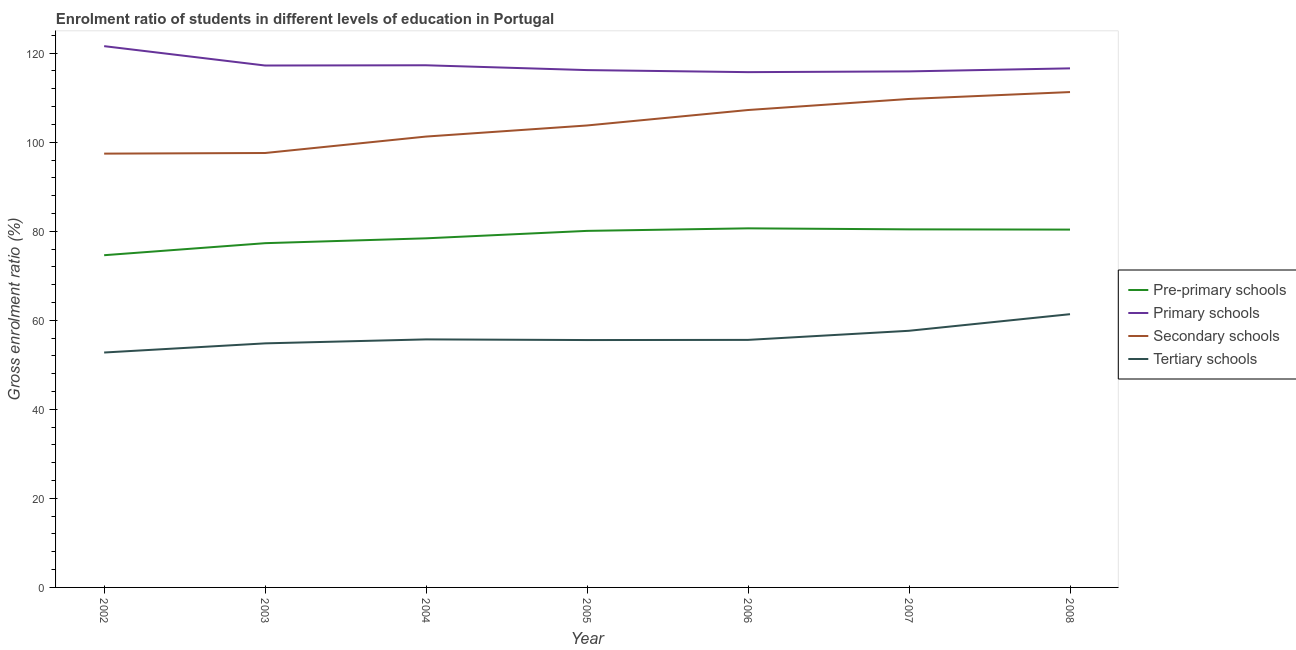Is the number of lines equal to the number of legend labels?
Keep it short and to the point. Yes. What is the gross enrolment ratio in primary schools in 2003?
Give a very brief answer. 117.22. Across all years, what is the maximum gross enrolment ratio in pre-primary schools?
Your response must be concise. 80.65. Across all years, what is the minimum gross enrolment ratio in pre-primary schools?
Give a very brief answer. 74.62. In which year was the gross enrolment ratio in pre-primary schools minimum?
Ensure brevity in your answer.  2002. What is the total gross enrolment ratio in primary schools in the graph?
Your answer should be very brief. 820.5. What is the difference between the gross enrolment ratio in tertiary schools in 2005 and that in 2008?
Your response must be concise. -5.81. What is the difference between the gross enrolment ratio in pre-primary schools in 2004 and the gross enrolment ratio in tertiary schools in 2006?
Your answer should be compact. 22.81. What is the average gross enrolment ratio in primary schools per year?
Provide a succinct answer. 117.21. In the year 2007, what is the difference between the gross enrolment ratio in tertiary schools and gross enrolment ratio in secondary schools?
Ensure brevity in your answer.  -52.07. What is the ratio of the gross enrolment ratio in primary schools in 2006 to that in 2007?
Provide a short and direct response. 1. Is the difference between the gross enrolment ratio in secondary schools in 2003 and 2005 greater than the difference between the gross enrolment ratio in pre-primary schools in 2003 and 2005?
Give a very brief answer. No. What is the difference between the highest and the second highest gross enrolment ratio in primary schools?
Your response must be concise. 4.3. What is the difference between the highest and the lowest gross enrolment ratio in primary schools?
Provide a short and direct response. 5.84. Is the sum of the gross enrolment ratio in tertiary schools in 2005 and 2006 greater than the maximum gross enrolment ratio in pre-primary schools across all years?
Provide a short and direct response. Yes. Is it the case that in every year, the sum of the gross enrolment ratio in pre-primary schools and gross enrolment ratio in tertiary schools is greater than the sum of gross enrolment ratio in primary schools and gross enrolment ratio in secondary schools?
Keep it short and to the point. No. Does the gross enrolment ratio in secondary schools monotonically increase over the years?
Offer a very short reply. Yes. Is the gross enrolment ratio in tertiary schools strictly less than the gross enrolment ratio in secondary schools over the years?
Ensure brevity in your answer.  Yes. How many lines are there?
Offer a very short reply. 4. Are the values on the major ticks of Y-axis written in scientific E-notation?
Your answer should be very brief. No. Does the graph contain any zero values?
Ensure brevity in your answer.  No. Where does the legend appear in the graph?
Your answer should be compact. Center right. How are the legend labels stacked?
Provide a short and direct response. Vertical. What is the title of the graph?
Ensure brevity in your answer.  Enrolment ratio of students in different levels of education in Portugal. What is the Gross enrolment ratio (%) in Pre-primary schools in 2002?
Provide a short and direct response. 74.62. What is the Gross enrolment ratio (%) in Primary schools in 2002?
Your answer should be very brief. 121.57. What is the Gross enrolment ratio (%) of Secondary schools in 2002?
Your answer should be very brief. 97.43. What is the Gross enrolment ratio (%) in Tertiary schools in 2002?
Offer a terse response. 52.76. What is the Gross enrolment ratio (%) of Pre-primary schools in 2003?
Offer a terse response. 77.32. What is the Gross enrolment ratio (%) in Primary schools in 2003?
Give a very brief answer. 117.22. What is the Gross enrolment ratio (%) of Secondary schools in 2003?
Provide a short and direct response. 97.58. What is the Gross enrolment ratio (%) in Tertiary schools in 2003?
Provide a succinct answer. 54.82. What is the Gross enrolment ratio (%) of Pre-primary schools in 2004?
Offer a very short reply. 78.41. What is the Gross enrolment ratio (%) in Primary schools in 2004?
Your answer should be compact. 117.28. What is the Gross enrolment ratio (%) of Secondary schools in 2004?
Provide a succinct answer. 101.27. What is the Gross enrolment ratio (%) of Tertiary schools in 2004?
Keep it short and to the point. 55.71. What is the Gross enrolment ratio (%) of Pre-primary schools in 2005?
Provide a short and direct response. 80.08. What is the Gross enrolment ratio (%) in Primary schools in 2005?
Your answer should be very brief. 116.2. What is the Gross enrolment ratio (%) in Secondary schools in 2005?
Provide a short and direct response. 103.76. What is the Gross enrolment ratio (%) in Tertiary schools in 2005?
Provide a succinct answer. 55.56. What is the Gross enrolment ratio (%) in Pre-primary schools in 2006?
Your answer should be compact. 80.65. What is the Gross enrolment ratio (%) of Primary schools in 2006?
Ensure brevity in your answer.  115.74. What is the Gross enrolment ratio (%) of Secondary schools in 2006?
Offer a very short reply. 107.23. What is the Gross enrolment ratio (%) in Tertiary schools in 2006?
Provide a succinct answer. 55.6. What is the Gross enrolment ratio (%) in Pre-primary schools in 2007?
Ensure brevity in your answer.  80.43. What is the Gross enrolment ratio (%) in Primary schools in 2007?
Offer a very short reply. 115.9. What is the Gross enrolment ratio (%) in Secondary schools in 2007?
Provide a short and direct response. 109.71. What is the Gross enrolment ratio (%) of Tertiary schools in 2007?
Offer a terse response. 57.64. What is the Gross enrolment ratio (%) in Pre-primary schools in 2008?
Provide a short and direct response. 80.37. What is the Gross enrolment ratio (%) of Primary schools in 2008?
Your answer should be compact. 116.58. What is the Gross enrolment ratio (%) in Secondary schools in 2008?
Offer a very short reply. 111.26. What is the Gross enrolment ratio (%) in Tertiary schools in 2008?
Give a very brief answer. 61.37. Across all years, what is the maximum Gross enrolment ratio (%) in Pre-primary schools?
Offer a terse response. 80.65. Across all years, what is the maximum Gross enrolment ratio (%) in Primary schools?
Make the answer very short. 121.57. Across all years, what is the maximum Gross enrolment ratio (%) of Secondary schools?
Offer a terse response. 111.26. Across all years, what is the maximum Gross enrolment ratio (%) of Tertiary schools?
Give a very brief answer. 61.37. Across all years, what is the minimum Gross enrolment ratio (%) of Pre-primary schools?
Offer a very short reply. 74.62. Across all years, what is the minimum Gross enrolment ratio (%) of Primary schools?
Ensure brevity in your answer.  115.74. Across all years, what is the minimum Gross enrolment ratio (%) in Secondary schools?
Your response must be concise. 97.43. Across all years, what is the minimum Gross enrolment ratio (%) of Tertiary schools?
Ensure brevity in your answer.  52.76. What is the total Gross enrolment ratio (%) in Pre-primary schools in the graph?
Your answer should be very brief. 551.88. What is the total Gross enrolment ratio (%) of Primary schools in the graph?
Provide a succinct answer. 820.5. What is the total Gross enrolment ratio (%) of Secondary schools in the graph?
Your answer should be compact. 728.24. What is the total Gross enrolment ratio (%) of Tertiary schools in the graph?
Offer a terse response. 393.47. What is the difference between the Gross enrolment ratio (%) in Pre-primary schools in 2002 and that in 2003?
Your response must be concise. -2.7. What is the difference between the Gross enrolment ratio (%) in Primary schools in 2002 and that in 2003?
Provide a short and direct response. 4.35. What is the difference between the Gross enrolment ratio (%) of Secondary schools in 2002 and that in 2003?
Offer a very short reply. -0.14. What is the difference between the Gross enrolment ratio (%) in Tertiary schools in 2002 and that in 2003?
Keep it short and to the point. -2.06. What is the difference between the Gross enrolment ratio (%) in Pre-primary schools in 2002 and that in 2004?
Make the answer very short. -3.79. What is the difference between the Gross enrolment ratio (%) in Primary schools in 2002 and that in 2004?
Make the answer very short. 4.3. What is the difference between the Gross enrolment ratio (%) in Secondary schools in 2002 and that in 2004?
Keep it short and to the point. -3.83. What is the difference between the Gross enrolment ratio (%) of Tertiary schools in 2002 and that in 2004?
Give a very brief answer. -2.95. What is the difference between the Gross enrolment ratio (%) of Pre-primary schools in 2002 and that in 2005?
Offer a very short reply. -5.47. What is the difference between the Gross enrolment ratio (%) in Primary schools in 2002 and that in 2005?
Your response must be concise. 5.38. What is the difference between the Gross enrolment ratio (%) in Secondary schools in 2002 and that in 2005?
Offer a terse response. -6.33. What is the difference between the Gross enrolment ratio (%) in Tertiary schools in 2002 and that in 2005?
Offer a very short reply. -2.8. What is the difference between the Gross enrolment ratio (%) in Pre-primary schools in 2002 and that in 2006?
Offer a terse response. -6.04. What is the difference between the Gross enrolment ratio (%) in Primary schools in 2002 and that in 2006?
Your answer should be compact. 5.84. What is the difference between the Gross enrolment ratio (%) in Secondary schools in 2002 and that in 2006?
Keep it short and to the point. -9.8. What is the difference between the Gross enrolment ratio (%) in Tertiary schools in 2002 and that in 2006?
Your response must be concise. -2.84. What is the difference between the Gross enrolment ratio (%) in Pre-primary schools in 2002 and that in 2007?
Give a very brief answer. -5.81. What is the difference between the Gross enrolment ratio (%) in Primary schools in 2002 and that in 2007?
Ensure brevity in your answer.  5.67. What is the difference between the Gross enrolment ratio (%) in Secondary schools in 2002 and that in 2007?
Offer a very short reply. -12.28. What is the difference between the Gross enrolment ratio (%) in Tertiary schools in 2002 and that in 2007?
Make the answer very short. -4.88. What is the difference between the Gross enrolment ratio (%) of Pre-primary schools in 2002 and that in 2008?
Ensure brevity in your answer.  -5.76. What is the difference between the Gross enrolment ratio (%) in Primary schools in 2002 and that in 2008?
Ensure brevity in your answer.  4.99. What is the difference between the Gross enrolment ratio (%) in Secondary schools in 2002 and that in 2008?
Keep it short and to the point. -13.83. What is the difference between the Gross enrolment ratio (%) in Tertiary schools in 2002 and that in 2008?
Offer a very short reply. -8.61. What is the difference between the Gross enrolment ratio (%) of Pre-primary schools in 2003 and that in 2004?
Provide a succinct answer. -1.09. What is the difference between the Gross enrolment ratio (%) of Primary schools in 2003 and that in 2004?
Provide a succinct answer. -0.06. What is the difference between the Gross enrolment ratio (%) of Secondary schools in 2003 and that in 2004?
Keep it short and to the point. -3.69. What is the difference between the Gross enrolment ratio (%) in Tertiary schools in 2003 and that in 2004?
Provide a succinct answer. -0.89. What is the difference between the Gross enrolment ratio (%) of Pre-primary schools in 2003 and that in 2005?
Ensure brevity in your answer.  -2.76. What is the difference between the Gross enrolment ratio (%) in Primary schools in 2003 and that in 2005?
Provide a succinct answer. 1.03. What is the difference between the Gross enrolment ratio (%) of Secondary schools in 2003 and that in 2005?
Make the answer very short. -6.18. What is the difference between the Gross enrolment ratio (%) of Tertiary schools in 2003 and that in 2005?
Offer a terse response. -0.75. What is the difference between the Gross enrolment ratio (%) of Pre-primary schools in 2003 and that in 2006?
Make the answer very short. -3.33. What is the difference between the Gross enrolment ratio (%) in Primary schools in 2003 and that in 2006?
Make the answer very short. 1.49. What is the difference between the Gross enrolment ratio (%) in Secondary schools in 2003 and that in 2006?
Keep it short and to the point. -9.65. What is the difference between the Gross enrolment ratio (%) in Tertiary schools in 2003 and that in 2006?
Offer a terse response. -0.78. What is the difference between the Gross enrolment ratio (%) in Pre-primary schools in 2003 and that in 2007?
Offer a terse response. -3.11. What is the difference between the Gross enrolment ratio (%) in Primary schools in 2003 and that in 2007?
Provide a succinct answer. 1.32. What is the difference between the Gross enrolment ratio (%) of Secondary schools in 2003 and that in 2007?
Offer a terse response. -12.14. What is the difference between the Gross enrolment ratio (%) in Tertiary schools in 2003 and that in 2007?
Give a very brief answer. -2.83. What is the difference between the Gross enrolment ratio (%) in Pre-primary schools in 2003 and that in 2008?
Keep it short and to the point. -3.05. What is the difference between the Gross enrolment ratio (%) in Primary schools in 2003 and that in 2008?
Your answer should be very brief. 0.64. What is the difference between the Gross enrolment ratio (%) in Secondary schools in 2003 and that in 2008?
Provide a short and direct response. -13.69. What is the difference between the Gross enrolment ratio (%) in Tertiary schools in 2003 and that in 2008?
Offer a very short reply. -6.55. What is the difference between the Gross enrolment ratio (%) of Pre-primary schools in 2004 and that in 2005?
Give a very brief answer. -1.67. What is the difference between the Gross enrolment ratio (%) in Primary schools in 2004 and that in 2005?
Your answer should be very brief. 1.08. What is the difference between the Gross enrolment ratio (%) in Secondary schools in 2004 and that in 2005?
Give a very brief answer. -2.49. What is the difference between the Gross enrolment ratio (%) in Tertiary schools in 2004 and that in 2005?
Your response must be concise. 0.15. What is the difference between the Gross enrolment ratio (%) in Pre-primary schools in 2004 and that in 2006?
Your answer should be compact. -2.24. What is the difference between the Gross enrolment ratio (%) in Primary schools in 2004 and that in 2006?
Your answer should be very brief. 1.54. What is the difference between the Gross enrolment ratio (%) of Secondary schools in 2004 and that in 2006?
Your response must be concise. -5.96. What is the difference between the Gross enrolment ratio (%) of Tertiary schools in 2004 and that in 2006?
Provide a succinct answer. 0.11. What is the difference between the Gross enrolment ratio (%) in Pre-primary schools in 2004 and that in 2007?
Your response must be concise. -2.01. What is the difference between the Gross enrolment ratio (%) in Primary schools in 2004 and that in 2007?
Offer a very short reply. 1.37. What is the difference between the Gross enrolment ratio (%) in Secondary schools in 2004 and that in 2007?
Offer a very short reply. -8.45. What is the difference between the Gross enrolment ratio (%) in Tertiary schools in 2004 and that in 2007?
Your answer should be very brief. -1.93. What is the difference between the Gross enrolment ratio (%) of Pre-primary schools in 2004 and that in 2008?
Provide a succinct answer. -1.96. What is the difference between the Gross enrolment ratio (%) of Primary schools in 2004 and that in 2008?
Provide a short and direct response. 0.69. What is the difference between the Gross enrolment ratio (%) of Secondary schools in 2004 and that in 2008?
Offer a terse response. -9.99. What is the difference between the Gross enrolment ratio (%) in Tertiary schools in 2004 and that in 2008?
Ensure brevity in your answer.  -5.66. What is the difference between the Gross enrolment ratio (%) in Pre-primary schools in 2005 and that in 2006?
Your response must be concise. -0.57. What is the difference between the Gross enrolment ratio (%) of Primary schools in 2005 and that in 2006?
Your answer should be very brief. 0.46. What is the difference between the Gross enrolment ratio (%) in Secondary schools in 2005 and that in 2006?
Ensure brevity in your answer.  -3.47. What is the difference between the Gross enrolment ratio (%) in Tertiary schools in 2005 and that in 2006?
Ensure brevity in your answer.  -0.04. What is the difference between the Gross enrolment ratio (%) in Pre-primary schools in 2005 and that in 2007?
Offer a terse response. -0.34. What is the difference between the Gross enrolment ratio (%) in Primary schools in 2005 and that in 2007?
Your response must be concise. 0.29. What is the difference between the Gross enrolment ratio (%) of Secondary schools in 2005 and that in 2007?
Provide a succinct answer. -5.95. What is the difference between the Gross enrolment ratio (%) in Tertiary schools in 2005 and that in 2007?
Give a very brief answer. -2.08. What is the difference between the Gross enrolment ratio (%) in Pre-primary schools in 2005 and that in 2008?
Ensure brevity in your answer.  -0.29. What is the difference between the Gross enrolment ratio (%) in Primary schools in 2005 and that in 2008?
Your response must be concise. -0.39. What is the difference between the Gross enrolment ratio (%) in Secondary schools in 2005 and that in 2008?
Your response must be concise. -7.5. What is the difference between the Gross enrolment ratio (%) of Tertiary schools in 2005 and that in 2008?
Provide a succinct answer. -5.81. What is the difference between the Gross enrolment ratio (%) of Pre-primary schools in 2006 and that in 2007?
Your answer should be very brief. 0.23. What is the difference between the Gross enrolment ratio (%) of Primary schools in 2006 and that in 2007?
Provide a short and direct response. -0.17. What is the difference between the Gross enrolment ratio (%) in Secondary schools in 2006 and that in 2007?
Give a very brief answer. -2.48. What is the difference between the Gross enrolment ratio (%) in Tertiary schools in 2006 and that in 2007?
Make the answer very short. -2.05. What is the difference between the Gross enrolment ratio (%) of Pre-primary schools in 2006 and that in 2008?
Keep it short and to the point. 0.28. What is the difference between the Gross enrolment ratio (%) of Primary schools in 2006 and that in 2008?
Keep it short and to the point. -0.85. What is the difference between the Gross enrolment ratio (%) of Secondary schools in 2006 and that in 2008?
Offer a very short reply. -4.03. What is the difference between the Gross enrolment ratio (%) in Tertiary schools in 2006 and that in 2008?
Your answer should be compact. -5.77. What is the difference between the Gross enrolment ratio (%) in Pre-primary schools in 2007 and that in 2008?
Give a very brief answer. 0.05. What is the difference between the Gross enrolment ratio (%) of Primary schools in 2007 and that in 2008?
Your answer should be compact. -0.68. What is the difference between the Gross enrolment ratio (%) of Secondary schools in 2007 and that in 2008?
Your answer should be very brief. -1.55. What is the difference between the Gross enrolment ratio (%) of Tertiary schools in 2007 and that in 2008?
Your answer should be very brief. -3.73. What is the difference between the Gross enrolment ratio (%) in Pre-primary schools in 2002 and the Gross enrolment ratio (%) in Primary schools in 2003?
Provide a succinct answer. -42.61. What is the difference between the Gross enrolment ratio (%) in Pre-primary schools in 2002 and the Gross enrolment ratio (%) in Secondary schools in 2003?
Your answer should be very brief. -22.96. What is the difference between the Gross enrolment ratio (%) of Pre-primary schools in 2002 and the Gross enrolment ratio (%) of Tertiary schools in 2003?
Provide a short and direct response. 19.8. What is the difference between the Gross enrolment ratio (%) in Primary schools in 2002 and the Gross enrolment ratio (%) in Secondary schools in 2003?
Offer a very short reply. 24. What is the difference between the Gross enrolment ratio (%) of Primary schools in 2002 and the Gross enrolment ratio (%) of Tertiary schools in 2003?
Ensure brevity in your answer.  66.76. What is the difference between the Gross enrolment ratio (%) of Secondary schools in 2002 and the Gross enrolment ratio (%) of Tertiary schools in 2003?
Provide a short and direct response. 42.62. What is the difference between the Gross enrolment ratio (%) in Pre-primary schools in 2002 and the Gross enrolment ratio (%) in Primary schools in 2004?
Provide a succinct answer. -42.66. What is the difference between the Gross enrolment ratio (%) in Pre-primary schools in 2002 and the Gross enrolment ratio (%) in Secondary schools in 2004?
Ensure brevity in your answer.  -26.65. What is the difference between the Gross enrolment ratio (%) of Pre-primary schools in 2002 and the Gross enrolment ratio (%) of Tertiary schools in 2004?
Your answer should be very brief. 18.91. What is the difference between the Gross enrolment ratio (%) in Primary schools in 2002 and the Gross enrolment ratio (%) in Secondary schools in 2004?
Your answer should be very brief. 20.31. What is the difference between the Gross enrolment ratio (%) of Primary schools in 2002 and the Gross enrolment ratio (%) of Tertiary schools in 2004?
Your response must be concise. 65.86. What is the difference between the Gross enrolment ratio (%) in Secondary schools in 2002 and the Gross enrolment ratio (%) in Tertiary schools in 2004?
Ensure brevity in your answer.  41.72. What is the difference between the Gross enrolment ratio (%) in Pre-primary schools in 2002 and the Gross enrolment ratio (%) in Primary schools in 2005?
Your response must be concise. -41.58. What is the difference between the Gross enrolment ratio (%) in Pre-primary schools in 2002 and the Gross enrolment ratio (%) in Secondary schools in 2005?
Ensure brevity in your answer.  -29.14. What is the difference between the Gross enrolment ratio (%) in Pre-primary schools in 2002 and the Gross enrolment ratio (%) in Tertiary schools in 2005?
Your answer should be compact. 19.05. What is the difference between the Gross enrolment ratio (%) in Primary schools in 2002 and the Gross enrolment ratio (%) in Secondary schools in 2005?
Your response must be concise. 17.82. What is the difference between the Gross enrolment ratio (%) in Primary schools in 2002 and the Gross enrolment ratio (%) in Tertiary schools in 2005?
Give a very brief answer. 66.01. What is the difference between the Gross enrolment ratio (%) in Secondary schools in 2002 and the Gross enrolment ratio (%) in Tertiary schools in 2005?
Your response must be concise. 41.87. What is the difference between the Gross enrolment ratio (%) in Pre-primary schools in 2002 and the Gross enrolment ratio (%) in Primary schools in 2006?
Your answer should be very brief. -41.12. What is the difference between the Gross enrolment ratio (%) of Pre-primary schools in 2002 and the Gross enrolment ratio (%) of Secondary schools in 2006?
Give a very brief answer. -32.61. What is the difference between the Gross enrolment ratio (%) in Pre-primary schools in 2002 and the Gross enrolment ratio (%) in Tertiary schools in 2006?
Give a very brief answer. 19.02. What is the difference between the Gross enrolment ratio (%) in Primary schools in 2002 and the Gross enrolment ratio (%) in Secondary schools in 2006?
Offer a terse response. 14.35. What is the difference between the Gross enrolment ratio (%) of Primary schools in 2002 and the Gross enrolment ratio (%) of Tertiary schools in 2006?
Offer a very short reply. 65.98. What is the difference between the Gross enrolment ratio (%) in Secondary schools in 2002 and the Gross enrolment ratio (%) in Tertiary schools in 2006?
Provide a succinct answer. 41.83. What is the difference between the Gross enrolment ratio (%) in Pre-primary schools in 2002 and the Gross enrolment ratio (%) in Primary schools in 2007?
Provide a short and direct response. -41.29. What is the difference between the Gross enrolment ratio (%) in Pre-primary schools in 2002 and the Gross enrolment ratio (%) in Secondary schools in 2007?
Make the answer very short. -35.1. What is the difference between the Gross enrolment ratio (%) in Pre-primary schools in 2002 and the Gross enrolment ratio (%) in Tertiary schools in 2007?
Provide a succinct answer. 16.97. What is the difference between the Gross enrolment ratio (%) of Primary schools in 2002 and the Gross enrolment ratio (%) of Secondary schools in 2007?
Offer a terse response. 11.86. What is the difference between the Gross enrolment ratio (%) of Primary schools in 2002 and the Gross enrolment ratio (%) of Tertiary schools in 2007?
Your answer should be compact. 63.93. What is the difference between the Gross enrolment ratio (%) of Secondary schools in 2002 and the Gross enrolment ratio (%) of Tertiary schools in 2007?
Offer a terse response. 39.79. What is the difference between the Gross enrolment ratio (%) in Pre-primary schools in 2002 and the Gross enrolment ratio (%) in Primary schools in 2008?
Offer a very short reply. -41.97. What is the difference between the Gross enrolment ratio (%) in Pre-primary schools in 2002 and the Gross enrolment ratio (%) in Secondary schools in 2008?
Give a very brief answer. -36.64. What is the difference between the Gross enrolment ratio (%) of Pre-primary schools in 2002 and the Gross enrolment ratio (%) of Tertiary schools in 2008?
Keep it short and to the point. 13.25. What is the difference between the Gross enrolment ratio (%) of Primary schools in 2002 and the Gross enrolment ratio (%) of Secondary schools in 2008?
Provide a short and direct response. 10.31. What is the difference between the Gross enrolment ratio (%) in Primary schools in 2002 and the Gross enrolment ratio (%) in Tertiary schools in 2008?
Your answer should be very brief. 60.2. What is the difference between the Gross enrolment ratio (%) of Secondary schools in 2002 and the Gross enrolment ratio (%) of Tertiary schools in 2008?
Make the answer very short. 36.06. What is the difference between the Gross enrolment ratio (%) of Pre-primary schools in 2003 and the Gross enrolment ratio (%) of Primary schools in 2004?
Your answer should be very brief. -39.96. What is the difference between the Gross enrolment ratio (%) of Pre-primary schools in 2003 and the Gross enrolment ratio (%) of Secondary schools in 2004?
Give a very brief answer. -23.95. What is the difference between the Gross enrolment ratio (%) in Pre-primary schools in 2003 and the Gross enrolment ratio (%) in Tertiary schools in 2004?
Ensure brevity in your answer.  21.61. What is the difference between the Gross enrolment ratio (%) of Primary schools in 2003 and the Gross enrolment ratio (%) of Secondary schools in 2004?
Make the answer very short. 15.95. What is the difference between the Gross enrolment ratio (%) in Primary schools in 2003 and the Gross enrolment ratio (%) in Tertiary schools in 2004?
Ensure brevity in your answer.  61.51. What is the difference between the Gross enrolment ratio (%) in Secondary schools in 2003 and the Gross enrolment ratio (%) in Tertiary schools in 2004?
Provide a succinct answer. 41.86. What is the difference between the Gross enrolment ratio (%) in Pre-primary schools in 2003 and the Gross enrolment ratio (%) in Primary schools in 2005?
Keep it short and to the point. -38.88. What is the difference between the Gross enrolment ratio (%) of Pre-primary schools in 2003 and the Gross enrolment ratio (%) of Secondary schools in 2005?
Your response must be concise. -26.44. What is the difference between the Gross enrolment ratio (%) in Pre-primary schools in 2003 and the Gross enrolment ratio (%) in Tertiary schools in 2005?
Offer a terse response. 21.76. What is the difference between the Gross enrolment ratio (%) of Primary schools in 2003 and the Gross enrolment ratio (%) of Secondary schools in 2005?
Provide a succinct answer. 13.46. What is the difference between the Gross enrolment ratio (%) of Primary schools in 2003 and the Gross enrolment ratio (%) of Tertiary schools in 2005?
Offer a very short reply. 61.66. What is the difference between the Gross enrolment ratio (%) of Secondary schools in 2003 and the Gross enrolment ratio (%) of Tertiary schools in 2005?
Ensure brevity in your answer.  42.01. What is the difference between the Gross enrolment ratio (%) of Pre-primary schools in 2003 and the Gross enrolment ratio (%) of Primary schools in 2006?
Your response must be concise. -38.42. What is the difference between the Gross enrolment ratio (%) of Pre-primary schools in 2003 and the Gross enrolment ratio (%) of Secondary schools in 2006?
Keep it short and to the point. -29.91. What is the difference between the Gross enrolment ratio (%) of Pre-primary schools in 2003 and the Gross enrolment ratio (%) of Tertiary schools in 2006?
Your answer should be compact. 21.72. What is the difference between the Gross enrolment ratio (%) of Primary schools in 2003 and the Gross enrolment ratio (%) of Secondary schools in 2006?
Keep it short and to the point. 9.99. What is the difference between the Gross enrolment ratio (%) in Primary schools in 2003 and the Gross enrolment ratio (%) in Tertiary schools in 2006?
Offer a terse response. 61.62. What is the difference between the Gross enrolment ratio (%) in Secondary schools in 2003 and the Gross enrolment ratio (%) in Tertiary schools in 2006?
Give a very brief answer. 41.98. What is the difference between the Gross enrolment ratio (%) in Pre-primary schools in 2003 and the Gross enrolment ratio (%) in Primary schools in 2007?
Provide a succinct answer. -38.58. What is the difference between the Gross enrolment ratio (%) of Pre-primary schools in 2003 and the Gross enrolment ratio (%) of Secondary schools in 2007?
Offer a very short reply. -32.39. What is the difference between the Gross enrolment ratio (%) of Pre-primary schools in 2003 and the Gross enrolment ratio (%) of Tertiary schools in 2007?
Your response must be concise. 19.68. What is the difference between the Gross enrolment ratio (%) of Primary schools in 2003 and the Gross enrolment ratio (%) of Secondary schools in 2007?
Your response must be concise. 7.51. What is the difference between the Gross enrolment ratio (%) in Primary schools in 2003 and the Gross enrolment ratio (%) in Tertiary schools in 2007?
Keep it short and to the point. 59.58. What is the difference between the Gross enrolment ratio (%) of Secondary schools in 2003 and the Gross enrolment ratio (%) of Tertiary schools in 2007?
Provide a succinct answer. 39.93. What is the difference between the Gross enrolment ratio (%) of Pre-primary schools in 2003 and the Gross enrolment ratio (%) of Primary schools in 2008?
Your response must be concise. -39.26. What is the difference between the Gross enrolment ratio (%) of Pre-primary schools in 2003 and the Gross enrolment ratio (%) of Secondary schools in 2008?
Make the answer very short. -33.94. What is the difference between the Gross enrolment ratio (%) of Pre-primary schools in 2003 and the Gross enrolment ratio (%) of Tertiary schools in 2008?
Ensure brevity in your answer.  15.95. What is the difference between the Gross enrolment ratio (%) in Primary schools in 2003 and the Gross enrolment ratio (%) in Secondary schools in 2008?
Provide a succinct answer. 5.96. What is the difference between the Gross enrolment ratio (%) in Primary schools in 2003 and the Gross enrolment ratio (%) in Tertiary schools in 2008?
Your answer should be compact. 55.85. What is the difference between the Gross enrolment ratio (%) in Secondary schools in 2003 and the Gross enrolment ratio (%) in Tertiary schools in 2008?
Give a very brief answer. 36.2. What is the difference between the Gross enrolment ratio (%) of Pre-primary schools in 2004 and the Gross enrolment ratio (%) of Primary schools in 2005?
Give a very brief answer. -37.78. What is the difference between the Gross enrolment ratio (%) of Pre-primary schools in 2004 and the Gross enrolment ratio (%) of Secondary schools in 2005?
Provide a short and direct response. -25.35. What is the difference between the Gross enrolment ratio (%) in Pre-primary schools in 2004 and the Gross enrolment ratio (%) in Tertiary schools in 2005?
Make the answer very short. 22.85. What is the difference between the Gross enrolment ratio (%) of Primary schools in 2004 and the Gross enrolment ratio (%) of Secondary schools in 2005?
Your answer should be compact. 13.52. What is the difference between the Gross enrolment ratio (%) in Primary schools in 2004 and the Gross enrolment ratio (%) in Tertiary schools in 2005?
Provide a succinct answer. 61.72. What is the difference between the Gross enrolment ratio (%) in Secondary schools in 2004 and the Gross enrolment ratio (%) in Tertiary schools in 2005?
Make the answer very short. 45.7. What is the difference between the Gross enrolment ratio (%) in Pre-primary schools in 2004 and the Gross enrolment ratio (%) in Primary schools in 2006?
Your response must be concise. -37.33. What is the difference between the Gross enrolment ratio (%) of Pre-primary schools in 2004 and the Gross enrolment ratio (%) of Secondary schools in 2006?
Offer a very short reply. -28.82. What is the difference between the Gross enrolment ratio (%) in Pre-primary schools in 2004 and the Gross enrolment ratio (%) in Tertiary schools in 2006?
Ensure brevity in your answer.  22.81. What is the difference between the Gross enrolment ratio (%) in Primary schools in 2004 and the Gross enrolment ratio (%) in Secondary schools in 2006?
Your answer should be compact. 10.05. What is the difference between the Gross enrolment ratio (%) in Primary schools in 2004 and the Gross enrolment ratio (%) in Tertiary schools in 2006?
Provide a succinct answer. 61.68. What is the difference between the Gross enrolment ratio (%) of Secondary schools in 2004 and the Gross enrolment ratio (%) of Tertiary schools in 2006?
Ensure brevity in your answer.  45.67. What is the difference between the Gross enrolment ratio (%) of Pre-primary schools in 2004 and the Gross enrolment ratio (%) of Primary schools in 2007?
Your answer should be compact. -37.49. What is the difference between the Gross enrolment ratio (%) in Pre-primary schools in 2004 and the Gross enrolment ratio (%) in Secondary schools in 2007?
Provide a succinct answer. -31.3. What is the difference between the Gross enrolment ratio (%) in Pre-primary schools in 2004 and the Gross enrolment ratio (%) in Tertiary schools in 2007?
Provide a short and direct response. 20.77. What is the difference between the Gross enrolment ratio (%) in Primary schools in 2004 and the Gross enrolment ratio (%) in Secondary schools in 2007?
Make the answer very short. 7.57. What is the difference between the Gross enrolment ratio (%) in Primary schools in 2004 and the Gross enrolment ratio (%) in Tertiary schools in 2007?
Offer a very short reply. 59.63. What is the difference between the Gross enrolment ratio (%) of Secondary schools in 2004 and the Gross enrolment ratio (%) of Tertiary schools in 2007?
Keep it short and to the point. 43.62. What is the difference between the Gross enrolment ratio (%) in Pre-primary schools in 2004 and the Gross enrolment ratio (%) in Primary schools in 2008?
Your answer should be very brief. -38.17. What is the difference between the Gross enrolment ratio (%) of Pre-primary schools in 2004 and the Gross enrolment ratio (%) of Secondary schools in 2008?
Your response must be concise. -32.85. What is the difference between the Gross enrolment ratio (%) in Pre-primary schools in 2004 and the Gross enrolment ratio (%) in Tertiary schools in 2008?
Provide a succinct answer. 17.04. What is the difference between the Gross enrolment ratio (%) of Primary schools in 2004 and the Gross enrolment ratio (%) of Secondary schools in 2008?
Keep it short and to the point. 6.02. What is the difference between the Gross enrolment ratio (%) in Primary schools in 2004 and the Gross enrolment ratio (%) in Tertiary schools in 2008?
Offer a very short reply. 55.91. What is the difference between the Gross enrolment ratio (%) in Secondary schools in 2004 and the Gross enrolment ratio (%) in Tertiary schools in 2008?
Offer a very short reply. 39.9. What is the difference between the Gross enrolment ratio (%) in Pre-primary schools in 2005 and the Gross enrolment ratio (%) in Primary schools in 2006?
Provide a succinct answer. -35.65. What is the difference between the Gross enrolment ratio (%) of Pre-primary schools in 2005 and the Gross enrolment ratio (%) of Secondary schools in 2006?
Your answer should be very brief. -27.15. What is the difference between the Gross enrolment ratio (%) in Pre-primary schools in 2005 and the Gross enrolment ratio (%) in Tertiary schools in 2006?
Your response must be concise. 24.48. What is the difference between the Gross enrolment ratio (%) of Primary schools in 2005 and the Gross enrolment ratio (%) of Secondary schools in 2006?
Keep it short and to the point. 8.97. What is the difference between the Gross enrolment ratio (%) of Primary schools in 2005 and the Gross enrolment ratio (%) of Tertiary schools in 2006?
Give a very brief answer. 60.6. What is the difference between the Gross enrolment ratio (%) of Secondary schools in 2005 and the Gross enrolment ratio (%) of Tertiary schools in 2006?
Provide a succinct answer. 48.16. What is the difference between the Gross enrolment ratio (%) in Pre-primary schools in 2005 and the Gross enrolment ratio (%) in Primary schools in 2007?
Give a very brief answer. -35.82. What is the difference between the Gross enrolment ratio (%) of Pre-primary schools in 2005 and the Gross enrolment ratio (%) of Secondary schools in 2007?
Your answer should be very brief. -29.63. What is the difference between the Gross enrolment ratio (%) of Pre-primary schools in 2005 and the Gross enrolment ratio (%) of Tertiary schools in 2007?
Offer a very short reply. 22.44. What is the difference between the Gross enrolment ratio (%) of Primary schools in 2005 and the Gross enrolment ratio (%) of Secondary schools in 2007?
Provide a succinct answer. 6.48. What is the difference between the Gross enrolment ratio (%) of Primary schools in 2005 and the Gross enrolment ratio (%) of Tertiary schools in 2007?
Offer a terse response. 58.55. What is the difference between the Gross enrolment ratio (%) in Secondary schools in 2005 and the Gross enrolment ratio (%) in Tertiary schools in 2007?
Provide a succinct answer. 46.11. What is the difference between the Gross enrolment ratio (%) of Pre-primary schools in 2005 and the Gross enrolment ratio (%) of Primary schools in 2008?
Provide a succinct answer. -36.5. What is the difference between the Gross enrolment ratio (%) in Pre-primary schools in 2005 and the Gross enrolment ratio (%) in Secondary schools in 2008?
Your answer should be very brief. -31.18. What is the difference between the Gross enrolment ratio (%) of Pre-primary schools in 2005 and the Gross enrolment ratio (%) of Tertiary schools in 2008?
Your answer should be very brief. 18.71. What is the difference between the Gross enrolment ratio (%) in Primary schools in 2005 and the Gross enrolment ratio (%) in Secondary schools in 2008?
Offer a terse response. 4.94. What is the difference between the Gross enrolment ratio (%) in Primary schools in 2005 and the Gross enrolment ratio (%) in Tertiary schools in 2008?
Provide a succinct answer. 54.82. What is the difference between the Gross enrolment ratio (%) of Secondary schools in 2005 and the Gross enrolment ratio (%) of Tertiary schools in 2008?
Ensure brevity in your answer.  42.39. What is the difference between the Gross enrolment ratio (%) of Pre-primary schools in 2006 and the Gross enrolment ratio (%) of Primary schools in 2007?
Your answer should be compact. -35.25. What is the difference between the Gross enrolment ratio (%) of Pre-primary schools in 2006 and the Gross enrolment ratio (%) of Secondary schools in 2007?
Provide a short and direct response. -29.06. What is the difference between the Gross enrolment ratio (%) of Pre-primary schools in 2006 and the Gross enrolment ratio (%) of Tertiary schools in 2007?
Keep it short and to the point. 23.01. What is the difference between the Gross enrolment ratio (%) in Primary schools in 2006 and the Gross enrolment ratio (%) in Secondary schools in 2007?
Your answer should be very brief. 6.02. What is the difference between the Gross enrolment ratio (%) in Primary schools in 2006 and the Gross enrolment ratio (%) in Tertiary schools in 2007?
Keep it short and to the point. 58.09. What is the difference between the Gross enrolment ratio (%) in Secondary schools in 2006 and the Gross enrolment ratio (%) in Tertiary schools in 2007?
Give a very brief answer. 49.58. What is the difference between the Gross enrolment ratio (%) in Pre-primary schools in 2006 and the Gross enrolment ratio (%) in Primary schools in 2008?
Your answer should be compact. -35.93. What is the difference between the Gross enrolment ratio (%) in Pre-primary schools in 2006 and the Gross enrolment ratio (%) in Secondary schools in 2008?
Provide a succinct answer. -30.61. What is the difference between the Gross enrolment ratio (%) of Pre-primary schools in 2006 and the Gross enrolment ratio (%) of Tertiary schools in 2008?
Keep it short and to the point. 19.28. What is the difference between the Gross enrolment ratio (%) of Primary schools in 2006 and the Gross enrolment ratio (%) of Secondary schools in 2008?
Keep it short and to the point. 4.48. What is the difference between the Gross enrolment ratio (%) in Primary schools in 2006 and the Gross enrolment ratio (%) in Tertiary schools in 2008?
Your response must be concise. 54.36. What is the difference between the Gross enrolment ratio (%) in Secondary schools in 2006 and the Gross enrolment ratio (%) in Tertiary schools in 2008?
Keep it short and to the point. 45.86. What is the difference between the Gross enrolment ratio (%) of Pre-primary schools in 2007 and the Gross enrolment ratio (%) of Primary schools in 2008?
Provide a short and direct response. -36.16. What is the difference between the Gross enrolment ratio (%) of Pre-primary schools in 2007 and the Gross enrolment ratio (%) of Secondary schools in 2008?
Keep it short and to the point. -30.83. What is the difference between the Gross enrolment ratio (%) of Pre-primary schools in 2007 and the Gross enrolment ratio (%) of Tertiary schools in 2008?
Make the answer very short. 19.05. What is the difference between the Gross enrolment ratio (%) in Primary schools in 2007 and the Gross enrolment ratio (%) in Secondary schools in 2008?
Your answer should be compact. 4.64. What is the difference between the Gross enrolment ratio (%) in Primary schools in 2007 and the Gross enrolment ratio (%) in Tertiary schools in 2008?
Your response must be concise. 54.53. What is the difference between the Gross enrolment ratio (%) of Secondary schools in 2007 and the Gross enrolment ratio (%) of Tertiary schools in 2008?
Your answer should be very brief. 48.34. What is the average Gross enrolment ratio (%) of Pre-primary schools per year?
Provide a succinct answer. 78.84. What is the average Gross enrolment ratio (%) in Primary schools per year?
Make the answer very short. 117.21. What is the average Gross enrolment ratio (%) of Secondary schools per year?
Give a very brief answer. 104.03. What is the average Gross enrolment ratio (%) in Tertiary schools per year?
Offer a very short reply. 56.21. In the year 2002, what is the difference between the Gross enrolment ratio (%) in Pre-primary schools and Gross enrolment ratio (%) in Primary schools?
Offer a terse response. -46.96. In the year 2002, what is the difference between the Gross enrolment ratio (%) of Pre-primary schools and Gross enrolment ratio (%) of Secondary schools?
Make the answer very short. -22.82. In the year 2002, what is the difference between the Gross enrolment ratio (%) in Pre-primary schools and Gross enrolment ratio (%) in Tertiary schools?
Your answer should be very brief. 21.86. In the year 2002, what is the difference between the Gross enrolment ratio (%) in Primary schools and Gross enrolment ratio (%) in Secondary schools?
Make the answer very short. 24.14. In the year 2002, what is the difference between the Gross enrolment ratio (%) of Primary schools and Gross enrolment ratio (%) of Tertiary schools?
Provide a short and direct response. 68.81. In the year 2002, what is the difference between the Gross enrolment ratio (%) of Secondary schools and Gross enrolment ratio (%) of Tertiary schools?
Make the answer very short. 44.67. In the year 2003, what is the difference between the Gross enrolment ratio (%) of Pre-primary schools and Gross enrolment ratio (%) of Primary schools?
Make the answer very short. -39.9. In the year 2003, what is the difference between the Gross enrolment ratio (%) in Pre-primary schools and Gross enrolment ratio (%) in Secondary schools?
Your answer should be compact. -20.26. In the year 2003, what is the difference between the Gross enrolment ratio (%) in Pre-primary schools and Gross enrolment ratio (%) in Tertiary schools?
Provide a succinct answer. 22.5. In the year 2003, what is the difference between the Gross enrolment ratio (%) of Primary schools and Gross enrolment ratio (%) of Secondary schools?
Your answer should be very brief. 19.65. In the year 2003, what is the difference between the Gross enrolment ratio (%) in Primary schools and Gross enrolment ratio (%) in Tertiary schools?
Give a very brief answer. 62.41. In the year 2003, what is the difference between the Gross enrolment ratio (%) of Secondary schools and Gross enrolment ratio (%) of Tertiary schools?
Your answer should be compact. 42.76. In the year 2004, what is the difference between the Gross enrolment ratio (%) of Pre-primary schools and Gross enrolment ratio (%) of Primary schools?
Provide a short and direct response. -38.87. In the year 2004, what is the difference between the Gross enrolment ratio (%) in Pre-primary schools and Gross enrolment ratio (%) in Secondary schools?
Give a very brief answer. -22.86. In the year 2004, what is the difference between the Gross enrolment ratio (%) of Pre-primary schools and Gross enrolment ratio (%) of Tertiary schools?
Your response must be concise. 22.7. In the year 2004, what is the difference between the Gross enrolment ratio (%) in Primary schools and Gross enrolment ratio (%) in Secondary schools?
Offer a very short reply. 16.01. In the year 2004, what is the difference between the Gross enrolment ratio (%) in Primary schools and Gross enrolment ratio (%) in Tertiary schools?
Provide a succinct answer. 61.57. In the year 2004, what is the difference between the Gross enrolment ratio (%) in Secondary schools and Gross enrolment ratio (%) in Tertiary schools?
Make the answer very short. 45.56. In the year 2005, what is the difference between the Gross enrolment ratio (%) in Pre-primary schools and Gross enrolment ratio (%) in Primary schools?
Your answer should be compact. -36.11. In the year 2005, what is the difference between the Gross enrolment ratio (%) of Pre-primary schools and Gross enrolment ratio (%) of Secondary schools?
Offer a very short reply. -23.68. In the year 2005, what is the difference between the Gross enrolment ratio (%) in Pre-primary schools and Gross enrolment ratio (%) in Tertiary schools?
Provide a short and direct response. 24.52. In the year 2005, what is the difference between the Gross enrolment ratio (%) in Primary schools and Gross enrolment ratio (%) in Secondary schools?
Give a very brief answer. 12.44. In the year 2005, what is the difference between the Gross enrolment ratio (%) in Primary schools and Gross enrolment ratio (%) in Tertiary schools?
Ensure brevity in your answer.  60.63. In the year 2005, what is the difference between the Gross enrolment ratio (%) in Secondary schools and Gross enrolment ratio (%) in Tertiary schools?
Make the answer very short. 48.2. In the year 2006, what is the difference between the Gross enrolment ratio (%) of Pre-primary schools and Gross enrolment ratio (%) of Primary schools?
Give a very brief answer. -35.08. In the year 2006, what is the difference between the Gross enrolment ratio (%) in Pre-primary schools and Gross enrolment ratio (%) in Secondary schools?
Provide a short and direct response. -26.58. In the year 2006, what is the difference between the Gross enrolment ratio (%) of Pre-primary schools and Gross enrolment ratio (%) of Tertiary schools?
Keep it short and to the point. 25.05. In the year 2006, what is the difference between the Gross enrolment ratio (%) of Primary schools and Gross enrolment ratio (%) of Secondary schools?
Keep it short and to the point. 8.51. In the year 2006, what is the difference between the Gross enrolment ratio (%) of Primary schools and Gross enrolment ratio (%) of Tertiary schools?
Your response must be concise. 60.14. In the year 2006, what is the difference between the Gross enrolment ratio (%) of Secondary schools and Gross enrolment ratio (%) of Tertiary schools?
Provide a short and direct response. 51.63. In the year 2007, what is the difference between the Gross enrolment ratio (%) in Pre-primary schools and Gross enrolment ratio (%) in Primary schools?
Provide a short and direct response. -35.48. In the year 2007, what is the difference between the Gross enrolment ratio (%) of Pre-primary schools and Gross enrolment ratio (%) of Secondary schools?
Offer a terse response. -29.29. In the year 2007, what is the difference between the Gross enrolment ratio (%) of Pre-primary schools and Gross enrolment ratio (%) of Tertiary schools?
Offer a very short reply. 22.78. In the year 2007, what is the difference between the Gross enrolment ratio (%) in Primary schools and Gross enrolment ratio (%) in Secondary schools?
Make the answer very short. 6.19. In the year 2007, what is the difference between the Gross enrolment ratio (%) of Primary schools and Gross enrolment ratio (%) of Tertiary schools?
Make the answer very short. 58.26. In the year 2007, what is the difference between the Gross enrolment ratio (%) in Secondary schools and Gross enrolment ratio (%) in Tertiary schools?
Your response must be concise. 52.07. In the year 2008, what is the difference between the Gross enrolment ratio (%) in Pre-primary schools and Gross enrolment ratio (%) in Primary schools?
Your response must be concise. -36.21. In the year 2008, what is the difference between the Gross enrolment ratio (%) of Pre-primary schools and Gross enrolment ratio (%) of Secondary schools?
Offer a terse response. -30.89. In the year 2008, what is the difference between the Gross enrolment ratio (%) of Pre-primary schools and Gross enrolment ratio (%) of Tertiary schools?
Your answer should be very brief. 19. In the year 2008, what is the difference between the Gross enrolment ratio (%) in Primary schools and Gross enrolment ratio (%) in Secondary schools?
Ensure brevity in your answer.  5.32. In the year 2008, what is the difference between the Gross enrolment ratio (%) of Primary schools and Gross enrolment ratio (%) of Tertiary schools?
Provide a short and direct response. 55.21. In the year 2008, what is the difference between the Gross enrolment ratio (%) in Secondary schools and Gross enrolment ratio (%) in Tertiary schools?
Give a very brief answer. 49.89. What is the ratio of the Gross enrolment ratio (%) of Primary schools in 2002 to that in 2003?
Keep it short and to the point. 1.04. What is the ratio of the Gross enrolment ratio (%) of Tertiary schools in 2002 to that in 2003?
Your response must be concise. 0.96. What is the ratio of the Gross enrolment ratio (%) in Pre-primary schools in 2002 to that in 2004?
Your answer should be compact. 0.95. What is the ratio of the Gross enrolment ratio (%) in Primary schools in 2002 to that in 2004?
Make the answer very short. 1.04. What is the ratio of the Gross enrolment ratio (%) of Secondary schools in 2002 to that in 2004?
Provide a short and direct response. 0.96. What is the ratio of the Gross enrolment ratio (%) in Tertiary schools in 2002 to that in 2004?
Provide a short and direct response. 0.95. What is the ratio of the Gross enrolment ratio (%) in Pre-primary schools in 2002 to that in 2005?
Ensure brevity in your answer.  0.93. What is the ratio of the Gross enrolment ratio (%) in Primary schools in 2002 to that in 2005?
Make the answer very short. 1.05. What is the ratio of the Gross enrolment ratio (%) of Secondary schools in 2002 to that in 2005?
Offer a very short reply. 0.94. What is the ratio of the Gross enrolment ratio (%) in Tertiary schools in 2002 to that in 2005?
Your response must be concise. 0.95. What is the ratio of the Gross enrolment ratio (%) in Pre-primary schools in 2002 to that in 2006?
Your response must be concise. 0.93. What is the ratio of the Gross enrolment ratio (%) of Primary schools in 2002 to that in 2006?
Offer a terse response. 1.05. What is the ratio of the Gross enrolment ratio (%) in Secondary schools in 2002 to that in 2006?
Your answer should be compact. 0.91. What is the ratio of the Gross enrolment ratio (%) of Tertiary schools in 2002 to that in 2006?
Give a very brief answer. 0.95. What is the ratio of the Gross enrolment ratio (%) of Pre-primary schools in 2002 to that in 2007?
Your answer should be compact. 0.93. What is the ratio of the Gross enrolment ratio (%) in Primary schools in 2002 to that in 2007?
Make the answer very short. 1.05. What is the ratio of the Gross enrolment ratio (%) of Secondary schools in 2002 to that in 2007?
Your answer should be compact. 0.89. What is the ratio of the Gross enrolment ratio (%) of Tertiary schools in 2002 to that in 2007?
Make the answer very short. 0.92. What is the ratio of the Gross enrolment ratio (%) in Pre-primary schools in 2002 to that in 2008?
Your response must be concise. 0.93. What is the ratio of the Gross enrolment ratio (%) in Primary schools in 2002 to that in 2008?
Offer a terse response. 1.04. What is the ratio of the Gross enrolment ratio (%) in Secondary schools in 2002 to that in 2008?
Provide a succinct answer. 0.88. What is the ratio of the Gross enrolment ratio (%) of Tertiary schools in 2002 to that in 2008?
Offer a terse response. 0.86. What is the ratio of the Gross enrolment ratio (%) of Pre-primary schools in 2003 to that in 2004?
Your answer should be compact. 0.99. What is the ratio of the Gross enrolment ratio (%) in Secondary schools in 2003 to that in 2004?
Your answer should be very brief. 0.96. What is the ratio of the Gross enrolment ratio (%) in Tertiary schools in 2003 to that in 2004?
Your answer should be very brief. 0.98. What is the ratio of the Gross enrolment ratio (%) of Pre-primary schools in 2003 to that in 2005?
Offer a terse response. 0.97. What is the ratio of the Gross enrolment ratio (%) of Primary schools in 2003 to that in 2005?
Your answer should be compact. 1.01. What is the ratio of the Gross enrolment ratio (%) of Secondary schools in 2003 to that in 2005?
Your answer should be compact. 0.94. What is the ratio of the Gross enrolment ratio (%) of Tertiary schools in 2003 to that in 2005?
Give a very brief answer. 0.99. What is the ratio of the Gross enrolment ratio (%) in Pre-primary schools in 2003 to that in 2006?
Give a very brief answer. 0.96. What is the ratio of the Gross enrolment ratio (%) of Primary schools in 2003 to that in 2006?
Keep it short and to the point. 1.01. What is the ratio of the Gross enrolment ratio (%) in Secondary schools in 2003 to that in 2006?
Keep it short and to the point. 0.91. What is the ratio of the Gross enrolment ratio (%) of Tertiary schools in 2003 to that in 2006?
Offer a very short reply. 0.99. What is the ratio of the Gross enrolment ratio (%) of Pre-primary schools in 2003 to that in 2007?
Provide a short and direct response. 0.96. What is the ratio of the Gross enrolment ratio (%) in Primary schools in 2003 to that in 2007?
Your response must be concise. 1.01. What is the ratio of the Gross enrolment ratio (%) in Secondary schools in 2003 to that in 2007?
Your answer should be compact. 0.89. What is the ratio of the Gross enrolment ratio (%) in Tertiary schools in 2003 to that in 2007?
Offer a very short reply. 0.95. What is the ratio of the Gross enrolment ratio (%) of Secondary schools in 2003 to that in 2008?
Provide a short and direct response. 0.88. What is the ratio of the Gross enrolment ratio (%) of Tertiary schools in 2003 to that in 2008?
Ensure brevity in your answer.  0.89. What is the ratio of the Gross enrolment ratio (%) of Pre-primary schools in 2004 to that in 2005?
Your response must be concise. 0.98. What is the ratio of the Gross enrolment ratio (%) in Primary schools in 2004 to that in 2005?
Your answer should be compact. 1.01. What is the ratio of the Gross enrolment ratio (%) in Pre-primary schools in 2004 to that in 2006?
Make the answer very short. 0.97. What is the ratio of the Gross enrolment ratio (%) in Primary schools in 2004 to that in 2006?
Provide a succinct answer. 1.01. What is the ratio of the Gross enrolment ratio (%) of Secondary schools in 2004 to that in 2006?
Provide a short and direct response. 0.94. What is the ratio of the Gross enrolment ratio (%) in Pre-primary schools in 2004 to that in 2007?
Make the answer very short. 0.97. What is the ratio of the Gross enrolment ratio (%) of Primary schools in 2004 to that in 2007?
Make the answer very short. 1.01. What is the ratio of the Gross enrolment ratio (%) in Secondary schools in 2004 to that in 2007?
Provide a succinct answer. 0.92. What is the ratio of the Gross enrolment ratio (%) of Tertiary schools in 2004 to that in 2007?
Provide a succinct answer. 0.97. What is the ratio of the Gross enrolment ratio (%) in Pre-primary schools in 2004 to that in 2008?
Make the answer very short. 0.98. What is the ratio of the Gross enrolment ratio (%) of Primary schools in 2004 to that in 2008?
Give a very brief answer. 1.01. What is the ratio of the Gross enrolment ratio (%) of Secondary schools in 2004 to that in 2008?
Offer a terse response. 0.91. What is the ratio of the Gross enrolment ratio (%) of Tertiary schools in 2004 to that in 2008?
Ensure brevity in your answer.  0.91. What is the ratio of the Gross enrolment ratio (%) of Pre-primary schools in 2005 to that in 2006?
Offer a terse response. 0.99. What is the ratio of the Gross enrolment ratio (%) of Primary schools in 2005 to that in 2006?
Your answer should be compact. 1. What is the ratio of the Gross enrolment ratio (%) in Secondary schools in 2005 to that in 2006?
Your response must be concise. 0.97. What is the ratio of the Gross enrolment ratio (%) of Pre-primary schools in 2005 to that in 2007?
Your answer should be very brief. 1. What is the ratio of the Gross enrolment ratio (%) of Secondary schools in 2005 to that in 2007?
Your response must be concise. 0.95. What is the ratio of the Gross enrolment ratio (%) of Tertiary schools in 2005 to that in 2007?
Keep it short and to the point. 0.96. What is the ratio of the Gross enrolment ratio (%) in Secondary schools in 2005 to that in 2008?
Keep it short and to the point. 0.93. What is the ratio of the Gross enrolment ratio (%) in Tertiary schools in 2005 to that in 2008?
Your answer should be very brief. 0.91. What is the ratio of the Gross enrolment ratio (%) in Pre-primary schools in 2006 to that in 2007?
Provide a short and direct response. 1. What is the ratio of the Gross enrolment ratio (%) in Primary schools in 2006 to that in 2007?
Your answer should be very brief. 1. What is the ratio of the Gross enrolment ratio (%) of Secondary schools in 2006 to that in 2007?
Your response must be concise. 0.98. What is the ratio of the Gross enrolment ratio (%) in Tertiary schools in 2006 to that in 2007?
Make the answer very short. 0.96. What is the ratio of the Gross enrolment ratio (%) in Secondary schools in 2006 to that in 2008?
Give a very brief answer. 0.96. What is the ratio of the Gross enrolment ratio (%) of Tertiary schools in 2006 to that in 2008?
Your answer should be compact. 0.91. What is the ratio of the Gross enrolment ratio (%) in Pre-primary schools in 2007 to that in 2008?
Make the answer very short. 1. What is the ratio of the Gross enrolment ratio (%) in Primary schools in 2007 to that in 2008?
Your response must be concise. 0.99. What is the ratio of the Gross enrolment ratio (%) in Secondary schools in 2007 to that in 2008?
Provide a succinct answer. 0.99. What is the ratio of the Gross enrolment ratio (%) in Tertiary schools in 2007 to that in 2008?
Offer a terse response. 0.94. What is the difference between the highest and the second highest Gross enrolment ratio (%) in Pre-primary schools?
Offer a terse response. 0.23. What is the difference between the highest and the second highest Gross enrolment ratio (%) of Primary schools?
Keep it short and to the point. 4.3. What is the difference between the highest and the second highest Gross enrolment ratio (%) in Secondary schools?
Give a very brief answer. 1.55. What is the difference between the highest and the second highest Gross enrolment ratio (%) in Tertiary schools?
Keep it short and to the point. 3.73. What is the difference between the highest and the lowest Gross enrolment ratio (%) of Pre-primary schools?
Offer a terse response. 6.04. What is the difference between the highest and the lowest Gross enrolment ratio (%) in Primary schools?
Keep it short and to the point. 5.84. What is the difference between the highest and the lowest Gross enrolment ratio (%) in Secondary schools?
Ensure brevity in your answer.  13.83. What is the difference between the highest and the lowest Gross enrolment ratio (%) in Tertiary schools?
Ensure brevity in your answer.  8.61. 